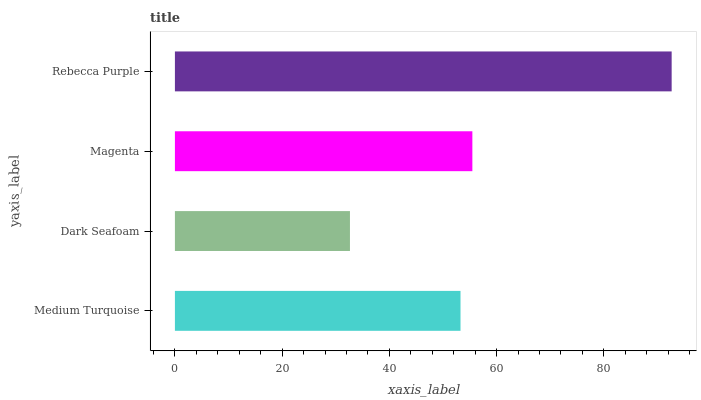Is Dark Seafoam the minimum?
Answer yes or no. Yes. Is Rebecca Purple the maximum?
Answer yes or no. Yes. Is Magenta the minimum?
Answer yes or no. No. Is Magenta the maximum?
Answer yes or no. No. Is Magenta greater than Dark Seafoam?
Answer yes or no. Yes. Is Dark Seafoam less than Magenta?
Answer yes or no. Yes. Is Dark Seafoam greater than Magenta?
Answer yes or no. No. Is Magenta less than Dark Seafoam?
Answer yes or no. No. Is Magenta the high median?
Answer yes or no. Yes. Is Medium Turquoise the low median?
Answer yes or no. Yes. Is Rebecca Purple the high median?
Answer yes or no. No. Is Dark Seafoam the low median?
Answer yes or no. No. 